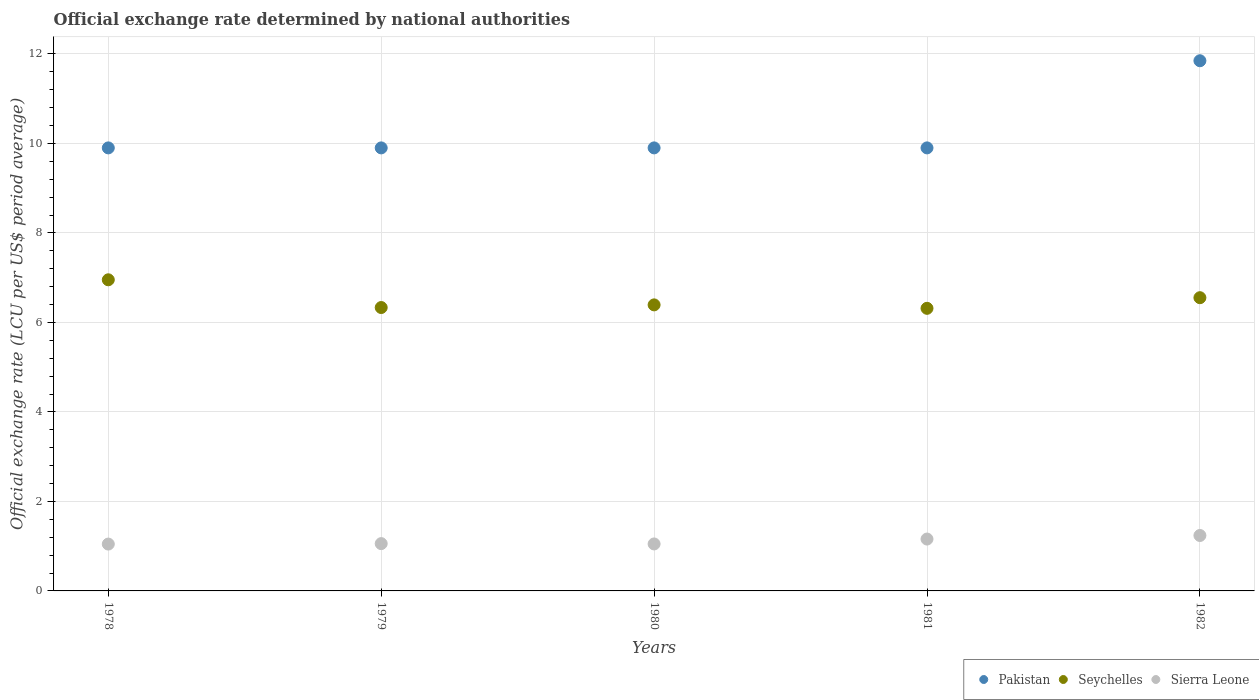What is the official exchange rate in Seychelles in 1978?
Keep it short and to the point. 6.95. Across all years, what is the maximum official exchange rate in Sierra Leone?
Your response must be concise. 1.24. In which year was the official exchange rate in Seychelles maximum?
Offer a terse response. 1978. In which year was the official exchange rate in Pakistan minimum?
Offer a very short reply. 1978. What is the total official exchange rate in Sierra Leone in the graph?
Your answer should be compact. 5.55. What is the difference between the official exchange rate in Sierra Leone in 1981 and the official exchange rate in Seychelles in 1978?
Offer a terse response. -5.79. What is the average official exchange rate in Sierra Leone per year?
Give a very brief answer. 1.11. In the year 1981, what is the difference between the official exchange rate in Pakistan and official exchange rate in Sierra Leone?
Provide a succinct answer. 8.74. What is the ratio of the official exchange rate in Seychelles in 1978 to that in 1981?
Make the answer very short. 1.1. What is the difference between the highest and the second highest official exchange rate in Pakistan?
Provide a succinct answer. 1.95. What is the difference between the highest and the lowest official exchange rate in Pakistan?
Offer a very short reply. 1.95. In how many years, is the official exchange rate in Pakistan greater than the average official exchange rate in Pakistan taken over all years?
Offer a very short reply. 1. Is the sum of the official exchange rate in Pakistan in 1979 and 1981 greater than the maximum official exchange rate in Seychelles across all years?
Keep it short and to the point. Yes. Is it the case that in every year, the sum of the official exchange rate in Seychelles and official exchange rate in Pakistan  is greater than the official exchange rate in Sierra Leone?
Offer a very short reply. Yes. Is the official exchange rate in Seychelles strictly greater than the official exchange rate in Pakistan over the years?
Give a very brief answer. No. Is the official exchange rate in Pakistan strictly less than the official exchange rate in Seychelles over the years?
Give a very brief answer. No. How many dotlines are there?
Give a very brief answer. 3. What is the difference between two consecutive major ticks on the Y-axis?
Keep it short and to the point. 2. Are the values on the major ticks of Y-axis written in scientific E-notation?
Offer a very short reply. No. Does the graph contain grids?
Provide a succinct answer. Yes. How are the legend labels stacked?
Your answer should be very brief. Horizontal. What is the title of the graph?
Offer a very short reply. Official exchange rate determined by national authorities. What is the label or title of the X-axis?
Keep it short and to the point. Years. What is the label or title of the Y-axis?
Ensure brevity in your answer.  Official exchange rate (LCU per US$ period average). What is the Official exchange rate (LCU per US$ period average) in Seychelles in 1978?
Your response must be concise. 6.95. What is the Official exchange rate (LCU per US$ period average) in Sierra Leone in 1978?
Your answer should be compact. 1.05. What is the Official exchange rate (LCU per US$ period average) of Seychelles in 1979?
Your answer should be very brief. 6.33. What is the Official exchange rate (LCU per US$ period average) of Sierra Leone in 1979?
Your response must be concise. 1.06. What is the Official exchange rate (LCU per US$ period average) in Pakistan in 1980?
Offer a very short reply. 9.9. What is the Official exchange rate (LCU per US$ period average) of Seychelles in 1980?
Your answer should be very brief. 6.39. What is the Official exchange rate (LCU per US$ period average) in Sierra Leone in 1980?
Give a very brief answer. 1.05. What is the Official exchange rate (LCU per US$ period average) in Seychelles in 1981?
Your answer should be compact. 6.31. What is the Official exchange rate (LCU per US$ period average) in Sierra Leone in 1981?
Ensure brevity in your answer.  1.16. What is the Official exchange rate (LCU per US$ period average) in Pakistan in 1982?
Your answer should be compact. 11.85. What is the Official exchange rate (LCU per US$ period average) of Seychelles in 1982?
Offer a very short reply. 6.55. What is the Official exchange rate (LCU per US$ period average) of Sierra Leone in 1982?
Provide a succinct answer. 1.24. Across all years, what is the maximum Official exchange rate (LCU per US$ period average) in Pakistan?
Your answer should be very brief. 11.85. Across all years, what is the maximum Official exchange rate (LCU per US$ period average) of Seychelles?
Ensure brevity in your answer.  6.95. Across all years, what is the maximum Official exchange rate (LCU per US$ period average) of Sierra Leone?
Provide a succinct answer. 1.24. Across all years, what is the minimum Official exchange rate (LCU per US$ period average) in Pakistan?
Keep it short and to the point. 9.9. Across all years, what is the minimum Official exchange rate (LCU per US$ period average) in Seychelles?
Your answer should be compact. 6.31. Across all years, what is the minimum Official exchange rate (LCU per US$ period average) of Sierra Leone?
Offer a terse response. 1.05. What is the total Official exchange rate (LCU per US$ period average) in Pakistan in the graph?
Your answer should be compact. 51.45. What is the total Official exchange rate (LCU per US$ period average) of Seychelles in the graph?
Your answer should be compact. 32.54. What is the total Official exchange rate (LCU per US$ period average) in Sierra Leone in the graph?
Provide a succinct answer. 5.55. What is the difference between the Official exchange rate (LCU per US$ period average) in Pakistan in 1978 and that in 1979?
Make the answer very short. 0. What is the difference between the Official exchange rate (LCU per US$ period average) in Seychelles in 1978 and that in 1979?
Provide a short and direct response. 0.62. What is the difference between the Official exchange rate (LCU per US$ period average) of Sierra Leone in 1978 and that in 1979?
Your answer should be very brief. -0.01. What is the difference between the Official exchange rate (LCU per US$ period average) of Pakistan in 1978 and that in 1980?
Your answer should be compact. 0. What is the difference between the Official exchange rate (LCU per US$ period average) of Seychelles in 1978 and that in 1980?
Make the answer very short. 0.56. What is the difference between the Official exchange rate (LCU per US$ period average) of Sierra Leone in 1978 and that in 1980?
Make the answer very short. -0. What is the difference between the Official exchange rate (LCU per US$ period average) of Pakistan in 1978 and that in 1981?
Your answer should be very brief. 0. What is the difference between the Official exchange rate (LCU per US$ period average) of Seychelles in 1978 and that in 1981?
Offer a terse response. 0.64. What is the difference between the Official exchange rate (LCU per US$ period average) in Sierra Leone in 1978 and that in 1981?
Your response must be concise. -0.11. What is the difference between the Official exchange rate (LCU per US$ period average) in Pakistan in 1978 and that in 1982?
Offer a terse response. -1.95. What is the difference between the Official exchange rate (LCU per US$ period average) of Seychelles in 1978 and that in 1982?
Your answer should be very brief. 0.4. What is the difference between the Official exchange rate (LCU per US$ period average) in Sierra Leone in 1978 and that in 1982?
Offer a terse response. -0.19. What is the difference between the Official exchange rate (LCU per US$ period average) in Pakistan in 1979 and that in 1980?
Provide a short and direct response. 0. What is the difference between the Official exchange rate (LCU per US$ period average) of Seychelles in 1979 and that in 1980?
Make the answer very short. -0.06. What is the difference between the Official exchange rate (LCU per US$ period average) of Sierra Leone in 1979 and that in 1980?
Give a very brief answer. 0.01. What is the difference between the Official exchange rate (LCU per US$ period average) of Seychelles in 1979 and that in 1981?
Provide a succinct answer. 0.02. What is the difference between the Official exchange rate (LCU per US$ period average) of Sierra Leone in 1979 and that in 1981?
Offer a terse response. -0.1. What is the difference between the Official exchange rate (LCU per US$ period average) of Pakistan in 1979 and that in 1982?
Provide a succinct answer. -1.95. What is the difference between the Official exchange rate (LCU per US$ period average) in Seychelles in 1979 and that in 1982?
Give a very brief answer. -0.22. What is the difference between the Official exchange rate (LCU per US$ period average) of Sierra Leone in 1979 and that in 1982?
Provide a short and direct response. -0.18. What is the difference between the Official exchange rate (LCU per US$ period average) in Seychelles in 1980 and that in 1981?
Provide a short and direct response. 0.08. What is the difference between the Official exchange rate (LCU per US$ period average) of Sierra Leone in 1980 and that in 1981?
Offer a terse response. -0.11. What is the difference between the Official exchange rate (LCU per US$ period average) in Pakistan in 1980 and that in 1982?
Provide a succinct answer. -1.95. What is the difference between the Official exchange rate (LCU per US$ period average) in Seychelles in 1980 and that in 1982?
Provide a short and direct response. -0.16. What is the difference between the Official exchange rate (LCU per US$ period average) of Sierra Leone in 1980 and that in 1982?
Make the answer very short. -0.19. What is the difference between the Official exchange rate (LCU per US$ period average) of Pakistan in 1981 and that in 1982?
Offer a very short reply. -1.95. What is the difference between the Official exchange rate (LCU per US$ period average) of Seychelles in 1981 and that in 1982?
Your answer should be compact. -0.24. What is the difference between the Official exchange rate (LCU per US$ period average) of Sierra Leone in 1981 and that in 1982?
Your answer should be very brief. -0.08. What is the difference between the Official exchange rate (LCU per US$ period average) in Pakistan in 1978 and the Official exchange rate (LCU per US$ period average) in Seychelles in 1979?
Offer a terse response. 3.57. What is the difference between the Official exchange rate (LCU per US$ period average) in Pakistan in 1978 and the Official exchange rate (LCU per US$ period average) in Sierra Leone in 1979?
Your response must be concise. 8.84. What is the difference between the Official exchange rate (LCU per US$ period average) of Seychelles in 1978 and the Official exchange rate (LCU per US$ period average) of Sierra Leone in 1979?
Your answer should be compact. 5.9. What is the difference between the Official exchange rate (LCU per US$ period average) of Pakistan in 1978 and the Official exchange rate (LCU per US$ period average) of Seychelles in 1980?
Your response must be concise. 3.51. What is the difference between the Official exchange rate (LCU per US$ period average) of Pakistan in 1978 and the Official exchange rate (LCU per US$ period average) of Sierra Leone in 1980?
Your answer should be very brief. 8.85. What is the difference between the Official exchange rate (LCU per US$ period average) of Seychelles in 1978 and the Official exchange rate (LCU per US$ period average) of Sierra Leone in 1980?
Offer a terse response. 5.9. What is the difference between the Official exchange rate (LCU per US$ period average) in Pakistan in 1978 and the Official exchange rate (LCU per US$ period average) in Seychelles in 1981?
Give a very brief answer. 3.59. What is the difference between the Official exchange rate (LCU per US$ period average) in Pakistan in 1978 and the Official exchange rate (LCU per US$ period average) in Sierra Leone in 1981?
Make the answer very short. 8.74. What is the difference between the Official exchange rate (LCU per US$ period average) of Seychelles in 1978 and the Official exchange rate (LCU per US$ period average) of Sierra Leone in 1981?
Provide a succinct answer. 5.79. What is the difference between the Official exchange rate (LCU per US$ period average) of Pakistan in 1978 and the Official exchange rate (LCU per US$ period average) of Seychelles in 1982?
Offer a very short reply. 3.35. What is the difference between the Official exchange rate (LCU per US$ period average) in Pakistan in 1978 and the Official exchange rate (LCU per US$ period average) in Sierra Leone in 1982?
Offer a terse response. 8.66. What is the difference between the Official exchange rate (LCU per US$ period average) in Seychelles in 1978 and the Official exchange rate (LCU per US$ period average) in Sierra Leone in 1982?
Keep it short and to the point. 5.71. What is the difference between the Official exchange rate (LCU per US$ period average) of Pakistan in 1979 and the Official exchange rate (LCU per US$ period average) of Seychelles in 1980?
Offer a terse response. 3.51. What is the difference between the Official exchange rate (LCU per US$ period average) of Pakistan in 1979 and the Official exchange rate (LCU per US$ period average) of Sierra Leone in 1980?
Provide a succinct answer. 8.85. What is the difference between the Official exchange rate (LCU per US$ period average) in Seychelles in 1979 and the Official exchange rate (LCU per US$ period average) in Sierra Leone in 1980?
Ensure brevity in your answer.  5.28. What is the difference between the Official exchange rate (LCU per US$ period average) of Pakistan in 1979 and the Official exchange rate (LCU per US$ period average) of Seychelles in 1981?
Provide a succinct answer. 3.59. What is the difference between the Official exchange rate (LCU per US$ period average) of Pakistan in 1979 and the Official exchange rate (LCU per US$ period average) of Sierra Leone in 1981?
Your response must be concise. 8.74. What is the difference between the Official exchange rate (LCU per US$ period average) in Seychelles in 1979 and the Official exchange rate (LCU per US$ period average) in Sierra Leone in 1981?
Your response must be concise. 5.17. What is the difference between the Official exchange rate (LCU per US$ period average) in Pakistan in 1979 and the Official exchange rate (LCU per US$ period average) in Seychelles in 1982?
Offer a terse response. 3.35. What is the difference between the Official exchange rate (LCU per US$ period average) of Pakistan in 1979 and the Official exchange rate (LCU per US$ period average) of Sierra Leone in 1982?
Offer a very short reply. 8.66. What is the difference between the Official exchange rate (LCU per US$ period average) of Seychelles in 1979 and the Official exchange rate (LCU per US$ period average) of Sierra Leone in 1982?
Keep it short and to the point. 5.09. What is the difference between the Official exchange rate (LCU per US$ period average) of Pakistan in 1980 and the Official exchange rate (LCU per US$ period average) of Seychelles in 1981?
Keep it short and to the point. 3.59. What is the difference between the Official exchange rate (LCU per US$ period average) of Pakistan in 1980 and the Official exchange rate (LCU per US$ period average) of Sierra Leone in 1981?
Make the answer very short. 8.74. What is the difference between the Official exchange rate (LCU per US$ period average) of Seychelles in 1980 and the Official exchange rate (LCU per US$ period average) of Sierra Leone in 1981?
Offer a very short reply. 5.23. What is the difference between the Official exchange rate (LCU per US$ period average) in Pakistan in 1980 and the Official exchange rate (LCU per US$ period average) in Seychelles in 1982?
Offer a terse response. 3.35. What is the difference between the Official exchange rate (LCU per US$ period average) in Pakistan in 1980 and the Official exchange rate (LCU per US$ period average) in Sierra Leone in 1982?
Keep it short and to the point. 8.66. What is the difference between the Official exchange rate (LCU per US$ period average) in Seychelles in 1980 and the Official exchange rate (LCU per US$ period average) in Sierra Leone in 1982?
Offer a terse response. 5.15. What is the difference between the Official exchange rate (LCU per US$ period average) of Pakistan in 1981 and the Official exchange rate (LCU per US$ period average) of Seychelles in 1982?
Offer a very short reply. 3.35. What is the difference between the Official exchange rate (LCU per US$ period average) in Pakistan in 1981 and the Official exchange rate (LCU per US$ period average) in Sierra Leone in 1982?
Offer a terse response. 8.66. What is the difference between the Official exchange rate (LCU per US$ period average) in Seychelles in 1981 and the Official exchange rate (LCU per US$ period average) in Sierra Leone in 1982?
Your response must be concise. 5.08. What is the average Official exchange rate (LCU per US$ period average) in Pakistan per year?
Ensure brevity in your answer.  10.29. What is the average Official exchange rate (LCU per US$ period average) of Seychelles per year?
Your response must be concise. 6.51. What is the average Official exchange rate (LCU per US$ period average) in Sierra Leone per year?
Offer a terse response. 1.11. In the year 1978, what is the difference between the Official exchange rate (LCU per US$ period average) of Pakistan and Official exchange rate (LCU per US$ period average) of Seychelles?
Offer a terse response. 2.95. In the year 1978, what is the difference between the Official exchange rate (LCU per US$ period average) in Pakistan and Official exchange rate (LCU per US$ period average) in Sierra Leone?
Keep it short and to the point. 8.85. In the year 1978, what is the difference between the Official exchange rate (LCU per US$ period average) of Seychelles and Official exchange rate (LCU per US$ period average) of Sierra Leone?
Offer a very short reply. 5.91. In the year 1979, what is the difference between the Official exchange rate (LCU per US$ period average) in Pakistan and Official exchange rate (LCU per US$ period average) in Seychelles?
Make the answer very short. 3.57. In the year 1979, what is the difference between the Official exchange rate (LCU per US$ period average) in Pakistan and Official exchange rate (LCU per US$ period average) in Sierra Leone?
Ensure brevity in your answer.  8.84. In the year 1979, what is the difference between the Official exchange rate (LCU per US$ period average) of Seychelles and Official exchange rate (LCU per US$ period average) of Sierra Leone?
Offer a very short reply. 5.28. In the year 1980, what is the difference between the Official exchange rate (LCU per US$ period average) of Pakistan and Official exchange rate (LCU per US$ period average) of Seychelles?
Offer a terse response. 3.51. In the year 1980, what is the difference between the Official exchange rate (LCU per US$ period average) of Pakistan and Official exchange rate (LCU per US$ period average) of Sierra Leone?
Make the answer very short. 8.85. In the year 1980, what is the difference between the Official exchange rate (LCU per US$ period average) of Seychelles and Official exchange rate (LCU per US$ period average) of Sierra Leone?
Make the answer very short. 5.34. In the year 1981, what is the difference between the Official exchange rate (LCU per US$ period average) of Pakistan and Official exchange rate (LCU per US$ period average) of Seychelles?
Offer a terse response. 3.59. In the year 1981, what is the difference between the Official exchange rate (LCU per US$ period average) in Pakistan and Official exchange rate (LCU per US$ period average) in Sierra Leone?
Provide a succinct answer. 8.74. In the year 1981, what is the difference between the Official exchange rate (LCU per US$ period average) in Seychelles and Official exchange rate (LCU per US$ period average) in Sierra Leone?
Keep it short and to the point. 5.16. In the year 1982, what is the difference between the Official exchange rate (LCU per US$ period average) in Pakistan and Official exchange rate (LCU per US$ period average) in Seychelles?
Your response must be concise. 5.29. In the year 1982, what is the difference between the Official exchange rate (LCU per US$ period average) in Pakistan and Official exchange rate (LCU per US$ period average) in Sierra Leone?
Make the answer very short. 10.61. In the year 1982, what is the difference between the Official exchange rate (LCU per US$ period average) in Seychelles and Official exchange rate (LCU per US$ period average) in Sierra Leone?
Ensure brevity in your answer.  5.31. What is the ratio of the Official exchange rate (LCU per US$ period average) of Seychelles in 1978 to that in 1979?
Your answer should be very brief. 1.1. What is the ratio of the Official exchange rate (LCU per US$ period average) of Sierra Leone in 1978 to that in 1979?
Give a very brief answer. 0.99. What is the ratio of the Official exchange rate (LCU per US$ period average) of Pakistan in 1978 to that in 1980?
Give a very brief answer. 1. What is the ratio of the Official exchange rate (LCU per US$ period average) of Seychelles in 1978 to that in 1980?
Ensure brevity in your answer.  1.09. What is the ratio of the Official exchange rate (LCU per US$ period average) in Seychelles in 1978 to that in 1981?
Ensure brevity in your answer.  1.1. What is the ratio of the Official exchange rate (LCU per US$ period average) of Sierra Leone in 1978 to that in 1981?
Ensure brevity in your answer.  0.9. What is the ratio of the Official exchange rate (LCU per US$ period average) of Pakistan in 1978 to that in 1982?
Offer a very short reply. 0.84. What is the ratio of the Official exchange rate (LCU per US$ period average) of Seychelles in 1978 to that in 1982?
Offer a very short reply. 1.06. What is the ratio of the Official exchange rate (LCU per US$ period average) in Sierra Leone in 1978 to that in 1982?
Give a very brief answer. 0.85. What is the ratio of the Official exchange rate (LCU per US$ period average) of Pakistan in 1979 to that in 1980?
Offer a terse response. 1. What is the ratio of the Official exchange rate (LCU per US$ period average) in Sierra Leone in 1979 to that in 1980?
Provide a succinct answer. 1.01. What is the ratio of the Official exchange rate (LCU per US$ period average) of Sierra Leone in 1979 to that in 1981?
Provide a short and direct response. 0.91. What is the ratio of the Official exchange rate (LCU per US$ period average) of Pakistan in 1979 to that in 1982?
Offer a terse response. 0.84. What is the ratio of the Official exchange rate (LCU per US$ period average) in Seychelles in 1979 to that in 1982?
Provide a short and direct response. 0.97. What is the ratio of the Official exchange rate (LCU per US$ period average) of Sierra Leone in 1979 to that in 1982?
Provide a short and direct response. 0.85. What is the ratio of the Official exchange rate (LCU per US$ period average) of Seychelles in 1980 to that in 1981?
Keep it short and to the point. 1.01. What is the ratio of the Official exchange rate (LCU per US$ period average) in Sierra Leone in 1980 to that in 1981?
Your response must be concise. 0.91. What is the ratio of the Official exchange rate (LCU per US$ period average) in Pakistan in 1980 to that in 1982?
Offer a very short reply. 0.84. What is the ratio of the Official exchange rate (LCU per US$ period average) of Seychelles in 1980 to that in 1982?
Your answer should be very brief. 0.98. What is the ratio of the Official exchange rate (LCU per US$ period average) in Sierra Leone in 1980 to that in 1982?
Provide a succinct answer. 0.85. What is the ratio of the Official exchange rate (LCU per US$ period average) of Pakistan in 1981 to that in 1982?
Give a very brief answer. 0.84. What is the ratio of the Official exchange rate (LCU per US$ period average) of Seychelles in 1981 to that in 1982?
Make the answer very short. 0.96. What is the ratio of the Official exchange rate (LCU per US$ period average) in Sierra Leone in 1981 to that in 1982?
Your answer should be compact. 0.94. What is the difference between the highest and the second highest Official exchange rate (LCU per US$ period average) of Pakistan?
Your answer should be very brief. 1.95. What is the difference between the highest and the second highest Official exchange rate (LCU per US$ period average) of Seychelles?
Ensure brevity in your answer.  0.4. What is the difference between the highest and the second highest Official exchange rate (LCU per US$ period average) of Sierra Leone?
Provide a short and direct response. 0.08. What is the difference between the highest and the lowest Official exchange rate (LCU per US$ period average) in Pakistan?
Keep it short and to the point. 1.95. What is the difference between the highest and the lowest Official exchange rate (LCU per US$ period average) in Seychelles?
Provide a short and direct response. 0.64. What is the difference between the highest and the lowest Official exchange rate (LCU per US$ period average) in Sierra Leone?
Offer a very short reply. 0.19. 